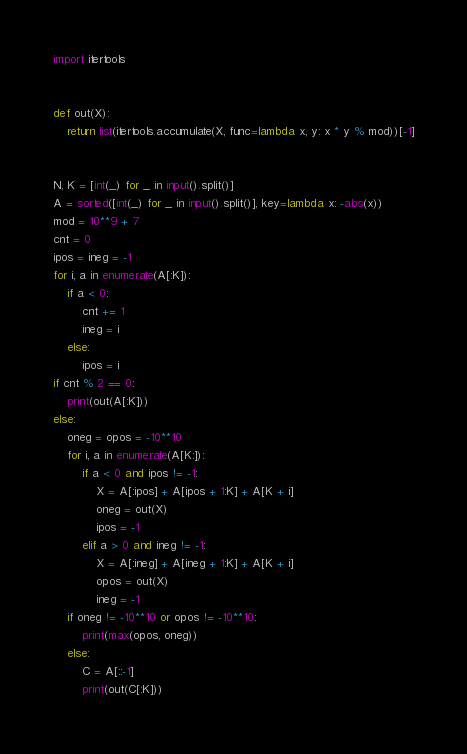<code> <loc_0><loc_0><loc_500><loc_500><_Python_>import itertools


def out(X):
    return list(itertools.accumulate(X, func=lambda x, y: x * y % mod))[-1]


N, K = [int(_) for _ in input().split()]
A = sorted([int(_) for _ in input().split()], key=lambda x: -abs(x))
mod = 10**9 + 7
cnt = 0
ipos = ineg = -1
for i, a in enumerate(A[:K]):
    if a < 0:
        cnt += 1
        ineg = i
    else:
        ipos = i
if cnt % 2 == 0:
    print(out(A[:K]))
else:
    oneg = opos = -10**10
    for i, a in enumerate(A[K:]):
        if a < 0 and ipos != -1:
            X = A[:ipos] + A[ipos + 1:K] + A[K + i]
            oneg = out(X)
            ipos = -1
        elif a > 0 and ineg != -1:
            X = A[:ineg] + A[ineg + 1:K] + A[K + i]
            opos = out(X)
            ineg = -1
    if oneg != -10**10 or opos != -10**10:
        print(max(opos, oneg))
    else:
        C = A[::-1]
        print(out(C[:K]))
</code> 